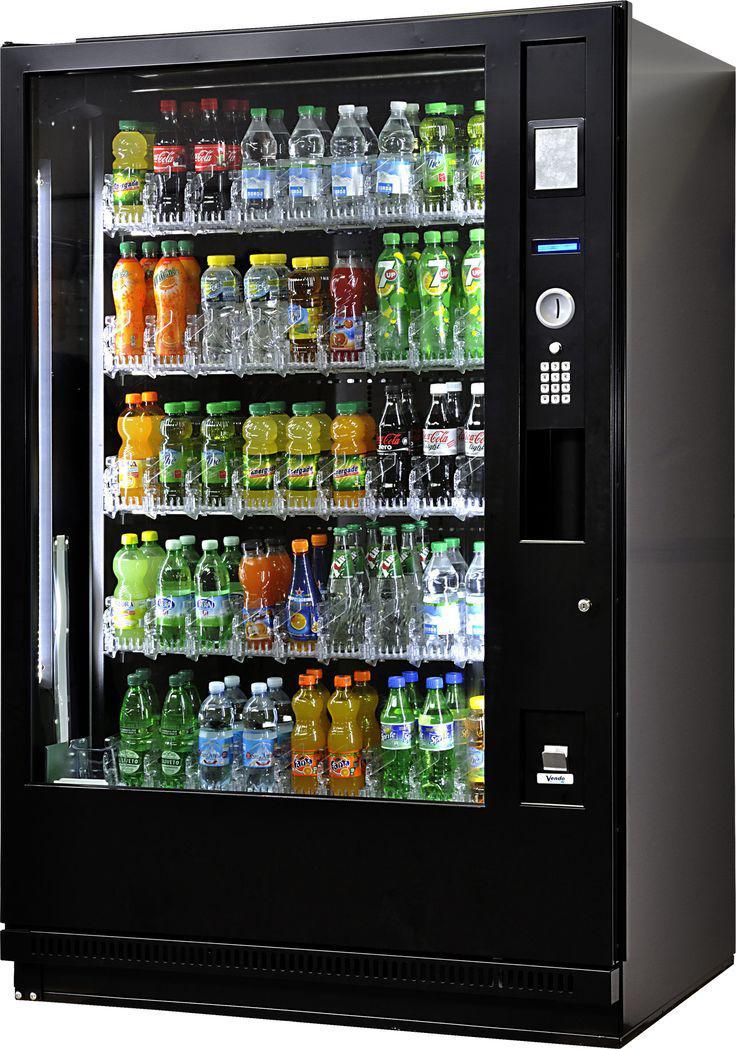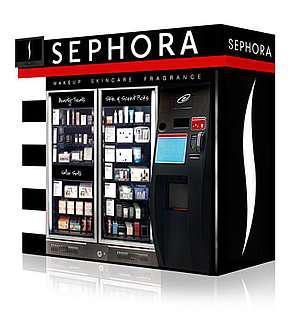The first image is the image on the left, the second image is the image on the right. Examine the images to the left and right. Is the description "There is exactly one vending machine in the image on the right." accurate? Answer yes or no. Yes. 